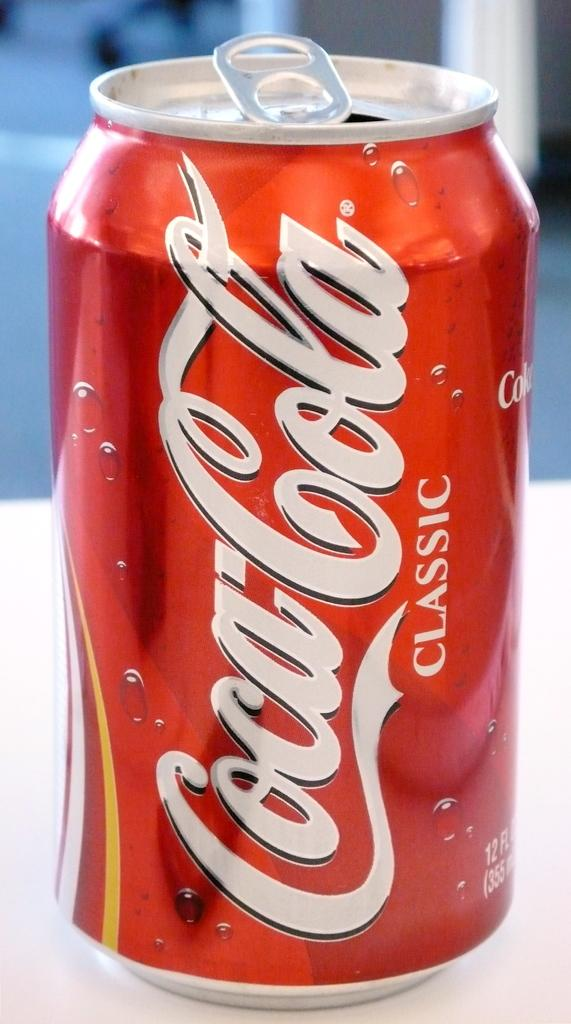<image>
Provide a brief description of the given image. A can of soda says Coca-Cola Classic and is on a white table. 